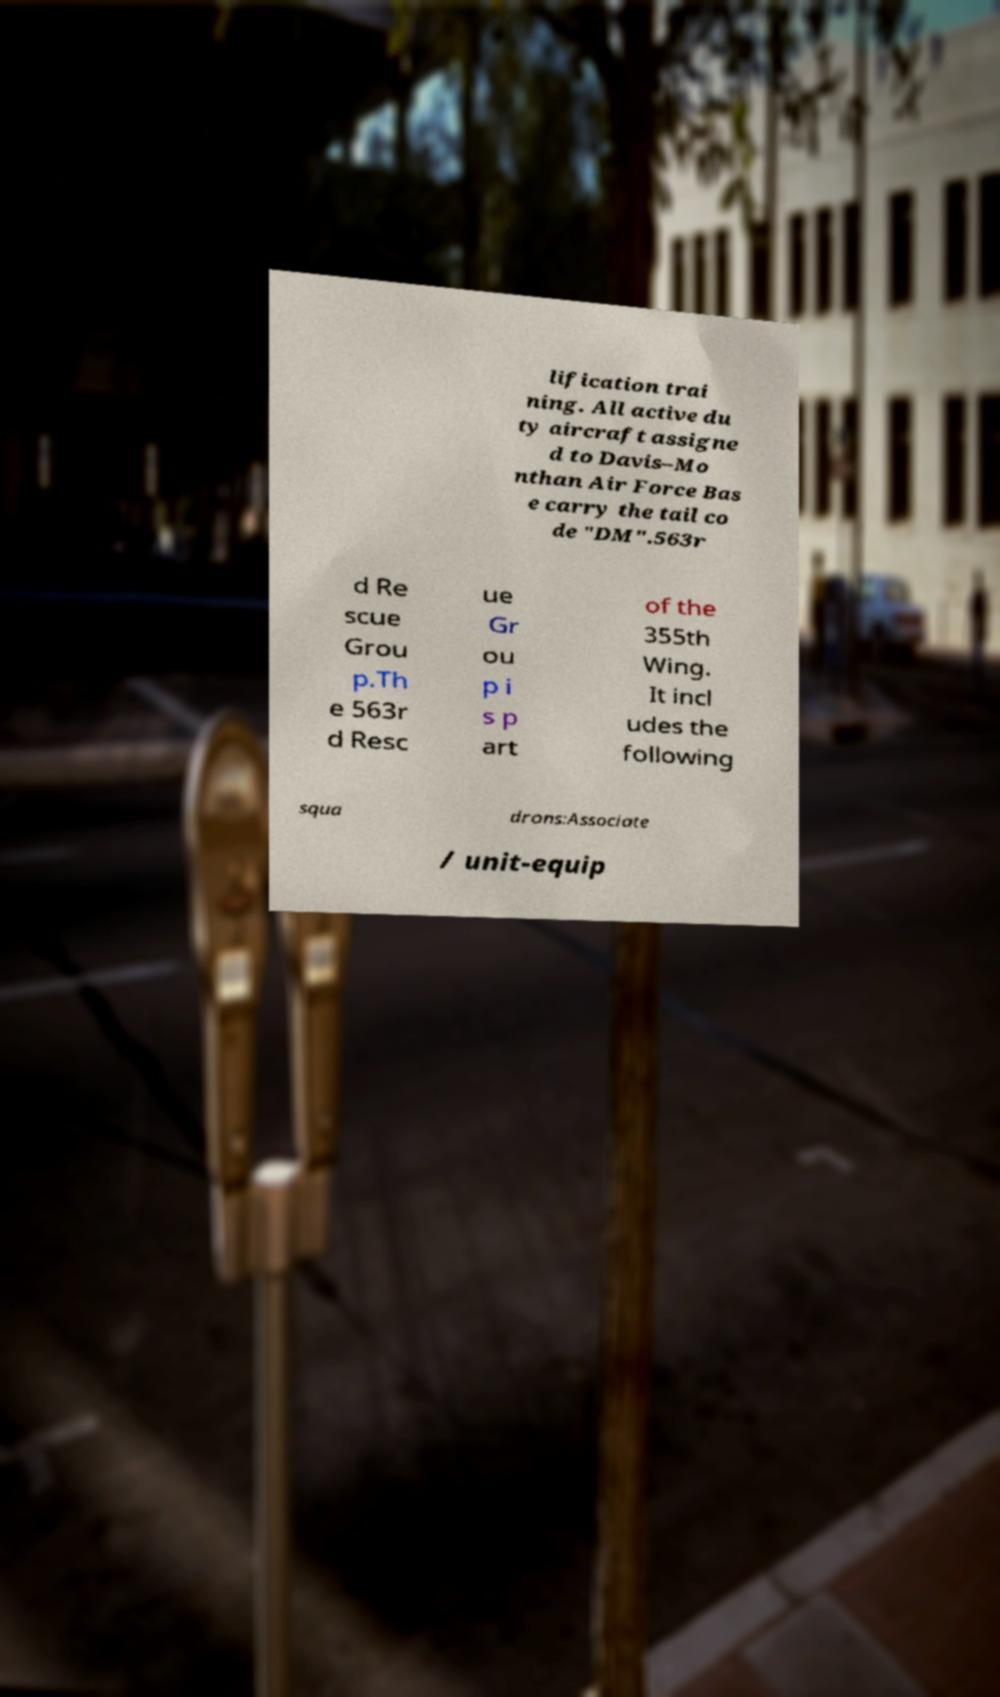What messages or text are displayed in this image? I need them in a readable, typed format. lification trai ning. All active du ty aircraft assigne d to Davis–Mo nthan Air Force Bas e carry the tail co de "DM".563r d Re scue Grou p.Th e 563r d Resc ue Gr ou p i s p art of the 355th Wing. It incl udes the following squa drons:Associate / unit-equip 